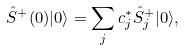<formula> <loc_0><loc_0><loc_500><loc_500>\hat { S } ^ { + } ( 0 ) | 0 \rangle = \sum _ { j } c ^ { * } _ { j } \hat { S } ^ { + } _ { j } | 0 \rangle ,</formula> 